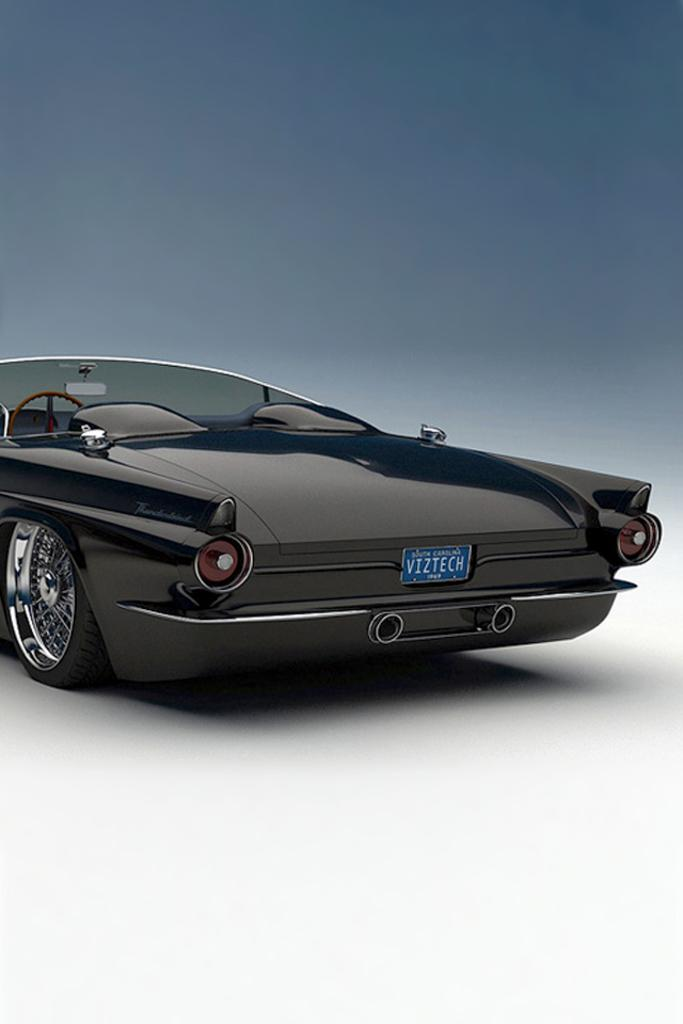What is the main subject of subject of the image? The main subject of the image is a car. Where is the car located in the image? The car is on a white color platform in the image. What can be observed about the background of the image? The background of the image appears to be gray. Can you tell me how many fingers the frog has in the image? There is no frog present in the image, so it is not possible to determine the number of fingers it might have. 